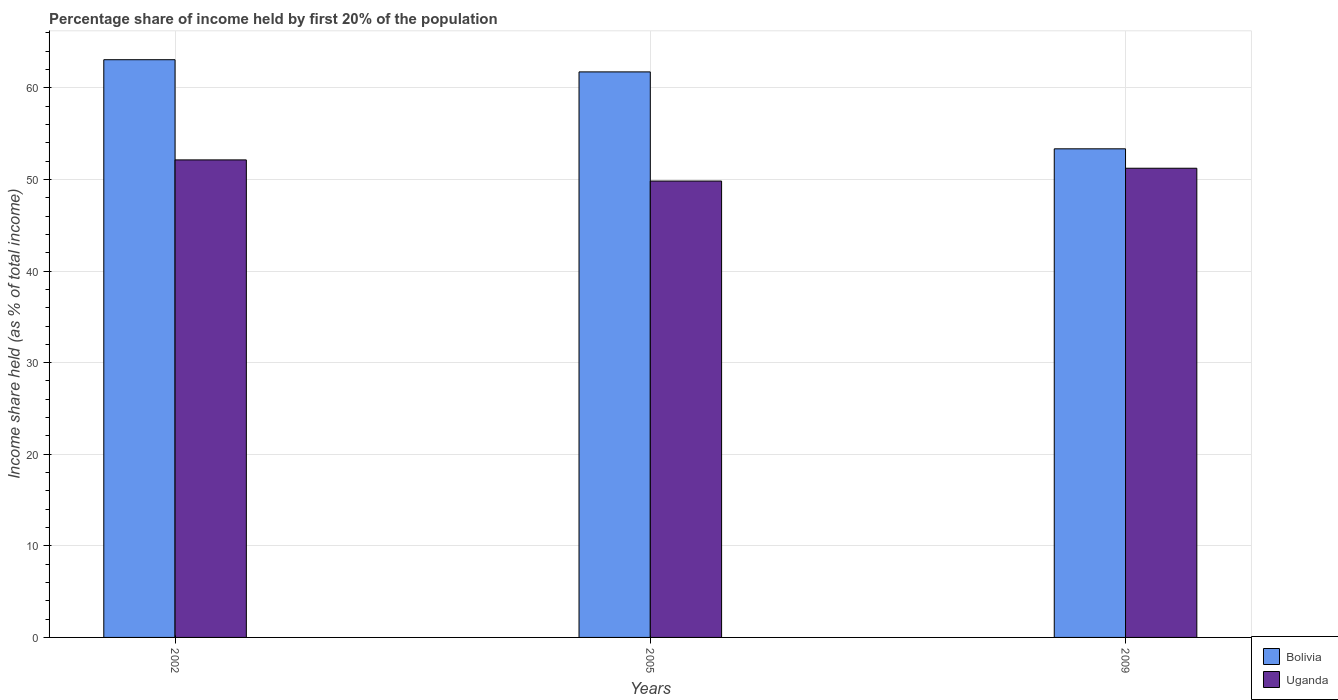How many different coloured bars are there?
Keep it short and to the point. 2. How many groups of bars are there?
Provide a short and direct response. 3. How many bars are there on the 3rd tick from the left?
Ensure brevity in your answer.  2. What is the label of the 2nd group of bars from the left?
Your answer should be very brief. 2005. What is the share of income held by first 20% of the population in Uganda in 2005?
Offer a very short reply. 49.83. Across all years, what is the maximum share of income held by first 20% of the population in Uganda?
Your answer should be very brief. 52.14. Across all years, what is the minimum share of income held by first 20% of the population in Bolivia?
Your response must be concise. 53.35. In which year was the share of income held by first 20% of the population in Uganda maximum?
Offer a terse response. 2002. What is the total share of income held by first 20% of the population in Uganda in the graph?
Offer a terse response. 153.2. What is the difference between the share of income held by first 20% of the population in Bolivia in 2005 and that in 2009?
Ensure brevity in your answer.  8.4. What is the difference between the share of income held by first 20% of the population in Uganda in 2009 and the share of income held by first 20% of the population in Bolivia in 2002?
Make the answer very short. -11.85. What is the average share of income held by first 20% of the population in Uganda per year?
Provide a short and direct response. 51.07. In the year 2005, what is the difference between the share of income held by first 20% of the population in Bolivia and share of income held by first 20% of the population in Uganda?
Your answer should be compact. 11.92. What is the ratio of the share of income held by first 20% of the population in Bolivia in 2002 to that in 2009?
Provide a short and direct response. 1.18. Is the share of income held by first 20% of the population in Uganda in 2005 less than that in 2009?
Make the answer very short. Yes. Is the difference between the share of income held by first 20% of the population in Bolivia in 2005 and 2009 greater than the difference between the share of income held by first 20% of the population in Uganda in 2005 and 2009?
Provide a succinct answer. Yes. What is the difference between the highest and the second highest share of income held by first 20% of the population in Uganda?
Give a very brief answer. 0.91. What is the difference between the highest and the lowest share of income held by first 20% of the population in Uganda?
Provide a short and direct response. 2.31. In how many years, is the share of income held by first 20% of the population in Uganda greater than the average share of income held by first 20% of the population in Uganda taken over all years?
Make the answer very short. 2. What does the 1st bar from the left in 2009 represents?
Ensure brevity in your answer.  Bolivia. What does the 2nd bar from the right in 2009 represents?
Make the answer very short. Bolivia. How many years are there in the graph?
Your answer should be compact. 3. What is the difference between two consecutive major ticks on the Y-axis?
Ensure brevity in your answer.  10. Where does the legend appear in the graph?
Your response must be concise. Bottom right. How many legend labels are there?
Give a very brief answer. 2. How are the legend labels stacked?
Keep it short and to the point. Vertical. What is the title of the graph?
Provide a short and direct response. Percentage share of income held by first 20% of the population. What is the label or title of the X-axis?
Offer a very short reply. Years. What is the label or title of the Y-axis?
Provide a short and direct response. Income share held (as % of total income). What is the Income share held (as % of total income) in Bolivia in 2002?
Your answer should be very brief. 63.08. What is the Income share held (as % of total income) of Uganda in 2002?
Offer a terse response. 52.14. What is the Income share held (as % of total income) of Bolivia in 2005?
Give a very brief answer. 61.75. What is the Income share held (as % of total income) of Uganda in 2005?
Keep it short and to the point. 49.83. What is the Income share held (as % of total income) of Bolivia in 2009?
Make the answer very short. 53.35. What is the Income share held (as % of total income) in Uganda in 2009?
Keep it short and to the point. 51.23. Across all years, what is the maximum Income share held (as % of total income) of Bolivia?
Your answer should be compact. 63.08. Across all years, what is the maximum Income share held (as % of total income) of Uganda?
Ensure brevity in your answer.  52.14. Across all years, what is the minimum Income share held (as % of total income) of Bolivia?
Offer a very short reply. 53.35. Across all years, what is the minimum Income share held (as % of total income) in Uganda?
Provide a succinct answer. 49.83. What is the total Income share held (as % of total income) of Bolivia in the graph?
Offer a terse response. 178.18. What is the total Income share held (as % of total income) in Uganda in the graph?
Your response must be concise. 153.2. What is the difference between the Income share held (as % of total income) of Bolivia in 2002 and that in 2005?
Offer a very short reply. 1.33. What is the difference between the Income share held (as % of total income) of Uganda in 2002 and that in 2005?
Offer a very short reply. 2.31. What is the difference between the Income share held (as % of total income) of Bolivia in 2002 and that in 2009?
Provide a short and direct response. 9.73. What is the difference between the Income share held (as % of total income) of Uganda in 2002 and that in 2009?
Your response must be concise. 0.91. What is the difference between the Income share held (as % of total income) of Bolivia in 2002 and the Income share held (as % of total income) of Uganda in 2005?
Make the answer very short. 13.25. What is the difference between the Income share held (as % of total income) in Bolivia in 2002 and the Income share held (as % of total income) in Uganda in 2009?
Provide a succinct answer. 11.85. What is the difference between the Income share held (as % of total income) in Bolivia in 2005 and the Income share held (as % of total income) in Uganda in 2009?
Provide a succinct answer. 10.52. What is the average Income share held (as % of total income) of Bolivia per year?
Give a very brief answer. 59.39. What is the average Income share held (as % of total income) of Uganda per year?
Provide a short and direct response. 51.07. In the year 2002, what is the difference between the Income share held (as % of total income) of Bolivia and Income share held (as % of total income) of Uganda?
Ensure brevity in your answer.  10.94. In the year 2005, what is the difference between the Income share held (as % of total income) in Bolivia and Income share held (as % of total income) in Uganda?
Give a very brief answer. 11.92. In the year 2009, what is the difference between the Income share held (as % of total income) of Bolivia and Income share held (as % of total income) of Uganda?
Your response must be concise. 2.12. What is the ratio of the Income share held (as % of total income) of Bolivia in 2002 to that in 2005?
Offer a very short reply. 1.02. What is the ratio of the Income share held (as % of total income) in Uganda in 2002 to that in 2005?
Your answer should be compact. 1.05. What is the ratio of the Income share held (as % of total income) of Bolivia in 2002 to that in 2009?
Make the answer very short. 1.18. What is the ratio of the Income share held (as % of total income) of Uganda in 2002 to that in 2009?
Ensure brevity in your answer.  1.02. What is the ratio of the Income share held (as % of total income) of Bolivia in 2005 to that in 2009?
Provide a short and direct response. 1.16. What is the ratio of the Income share held (as % of total income) in Uganda in 2005 to that in 2009?
Your answer should be very brief. 0.97. What is the difference between the highest and the second highest Income share held (as % of total income) in Bolivia?
Make the answer very short. 1.33. What is the difference between the highest and the second highest Income share held (as % of total income) of Uganda?
Make the answer very short. 0.91. What is the difference between the highest and the lowest Income share held (as % of total income) of Bolivia?
Make the answer very short. 9.73. What is the difference between the highest and the lowest Income share held (as % of total income) of Uganda?
Offer a terse response. 2.31. 